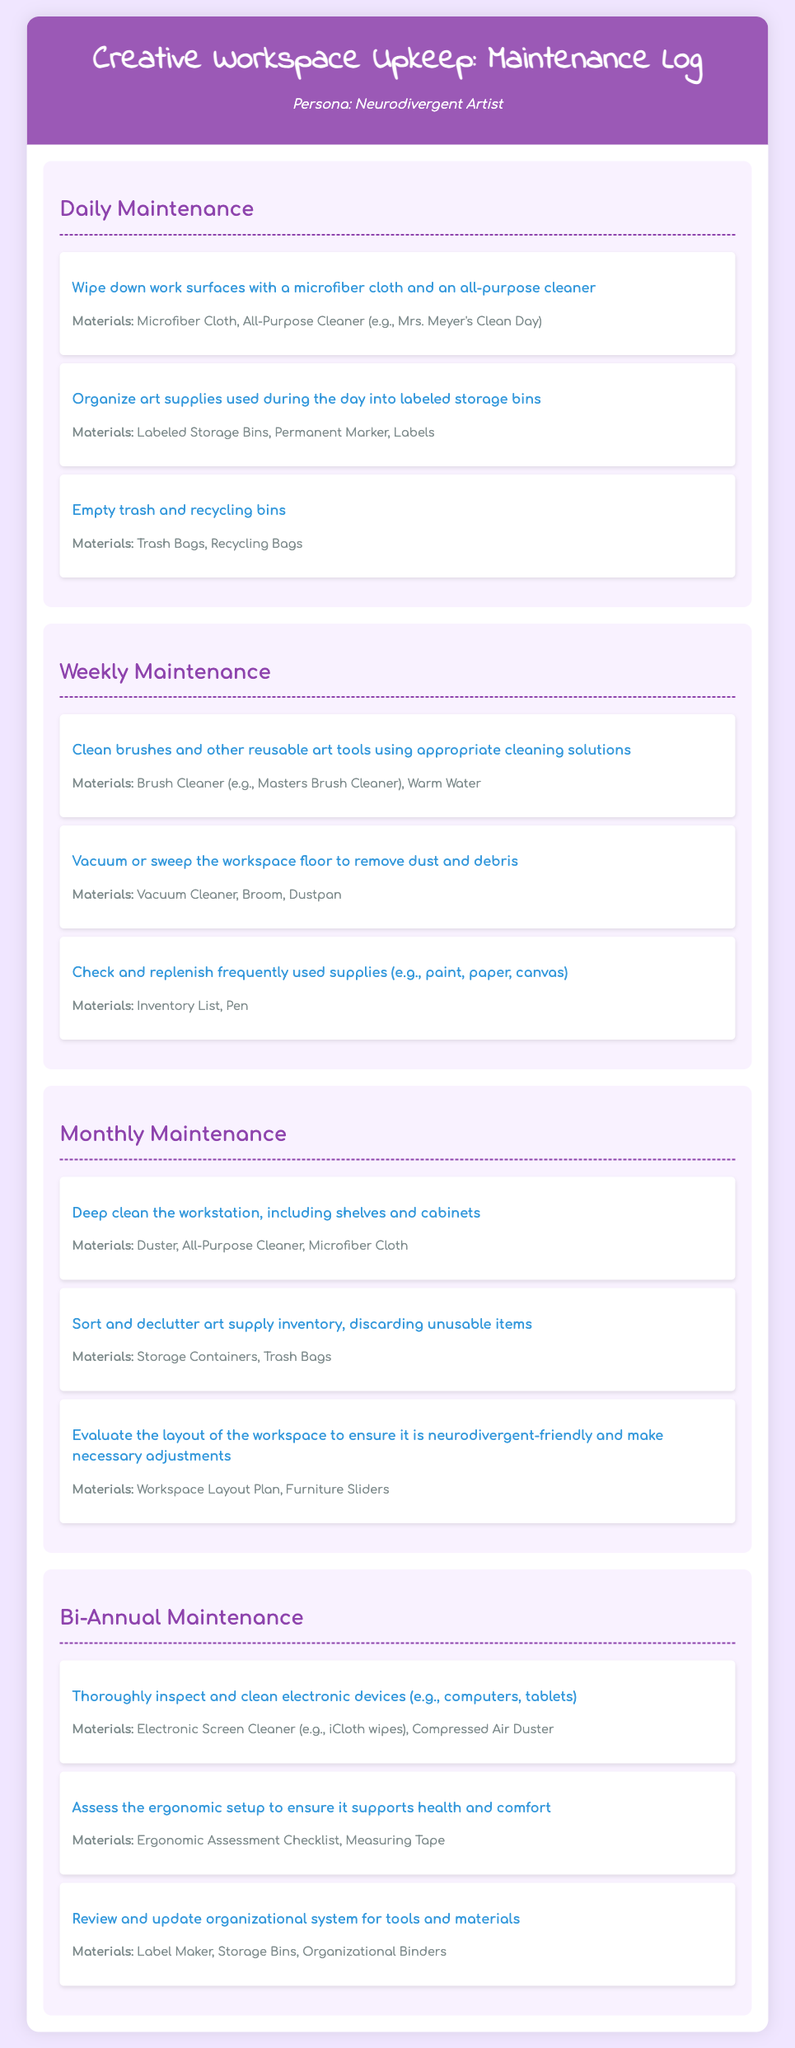What is the frequency of daily maintenance tasks? The frequency of daily maintenance tasks is mentioned in the section header, which states "Daily Maintenance."
Answer: Daily What materials are used for wiping down work surfaces? The materials listed for this task are specified within the daily maintenance task description.
Answer: Microfiber Cloth, All-Purpose Cleaner What cleaning solution is recommended for brushes? The document specifies the cleaning solution used for brushes in the weekly maintenance section.
Answer: Brush Cleaner What is required for checking and replenishing supplies? The materials needed for this task are noted in the weekly maintenance section of the document.
Answer: Inventory List, Pen What is one bi-annual maintenance task? The tasks listed under the bi-annual section provide specific cleaning or organization actions.
Answer: Inspect and clean electronic devices How often should art supply inventory be sorted and decluttered? This is indicated by the "Monthly Maintenance" heading, showing how frequently it should occur.
Answer: Monthly What type of cloth is used for cleaning electronic devices? The materials mentioned specifically for electronic device cleaning include a type of cloth.
Answer: Electronic Screen Cleaner What is the purpose of evaluating the workspace layout? The purpose is described in the monthly maintenance section focusing on the needs of neurodivergent individuals.
Answer: To ensure it is neurodivergent-friendly 